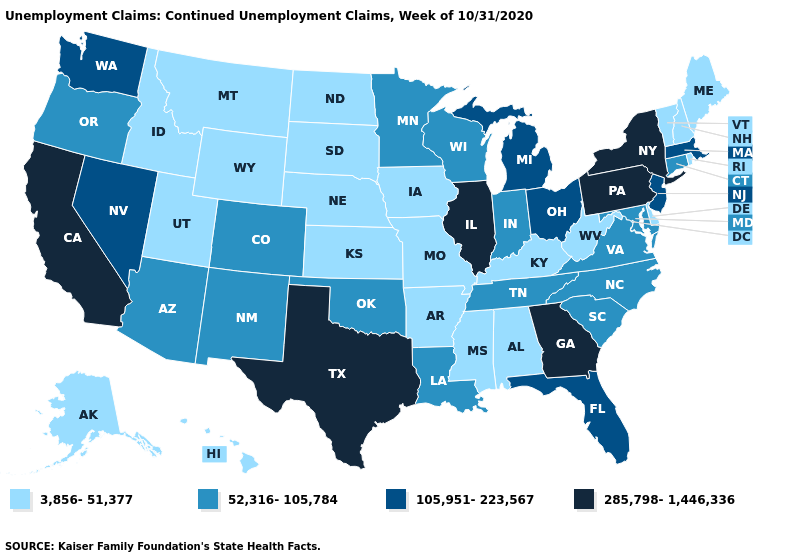What is the highest value in the USA?
Answer briefly. 285,798-1,446,336. What is the highest value in states that border Utah?
Short answer required. 105,951-223,567. Does Vermont have the lowest value in the Northeast?
Answer briefly. Yes. Name the states that have a value in the range 52,316-105,784?
Short answer required. Arizona, Colorado, Connecticut, Indiana, Louisiana, Maryland, Minnesota, New Mexico, North Carolina, Oklahoma, Oregon, South Carolina, Tennessee, Virginia, Wisconsin. Name the states that have a value in the range 285,798-1,446,336?
Keep it brief. California, Georgia, Illinois, New York, Pennsylvania, Texas. Name the states that have a value in the range 3,856-51,377?
Give a very brief answer. Alabama, Alaska, Arkansas, Delaware, Hawaii, Idaho, Iowa, Kansas, Kentucky, Maine, Mississippi, Missouri, Montana, Nebraska, New Hampshire, North Dakota, Rhode Island, South Dakota, Utah, Vermont, West Virginia, Wyoming. What is the highest value in states that border Wyoming?
Short answer required. 52,316-105,784. Name the states that have a value in the range 105,951-223,567?
Give a very brief answer. Florida, Massachusetts, Michigan, Nevada, New Jersey, Ohio, Washington. Does Illinois have the highest value in the MidWest?
Answer briefly. Yes. Which states have the lowest value in the Northeast?
Be succinct. Maine, New Hampshire, Rhode Island, Vermont. What is the value of Idaho?
Short answer required. 3,856-51,377. What is the value of Louisiana?
Answer briefly. 52,316-105,784. What is the value of Georgia?
Short answer required. 285,798-1,446,336. Does Michigan have the highest value in the USA?
Be succinct. No. What is the value of Pennsylvania?
Answer briefly. 285,798-1,446,336. 